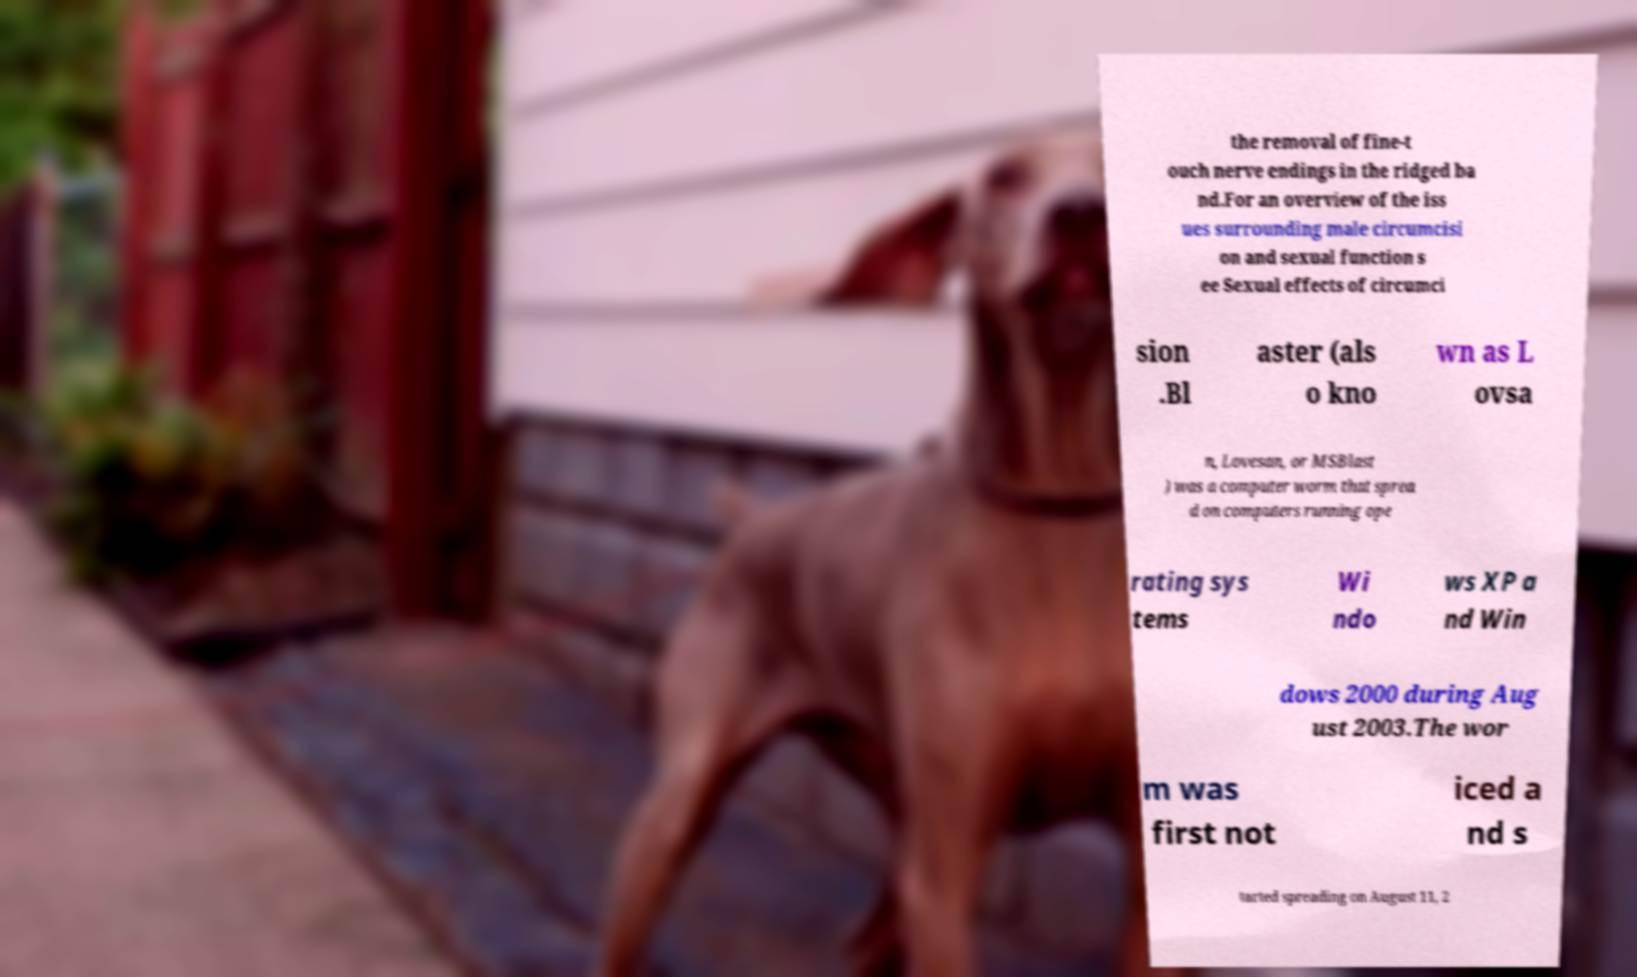Can you accurately transcribe the text from the provided image for me? the removal of fine-t ouch nerve endings in the ridged ba nd.For an overview of the iss ues surrounding male circumcisi on and sexual function s ee Sexual effects of circumci sion .Bl aster (als o kno wn as L ovsa n, Lovesan, or MSBlast ) was a computer worm that sprea d on computers running ope rating sys tems Wi ndo ws XP a nd Win dows 2000 during Aug ust 2003.The wor m was first not iced a nd s tarted spreading on August 11, 2 